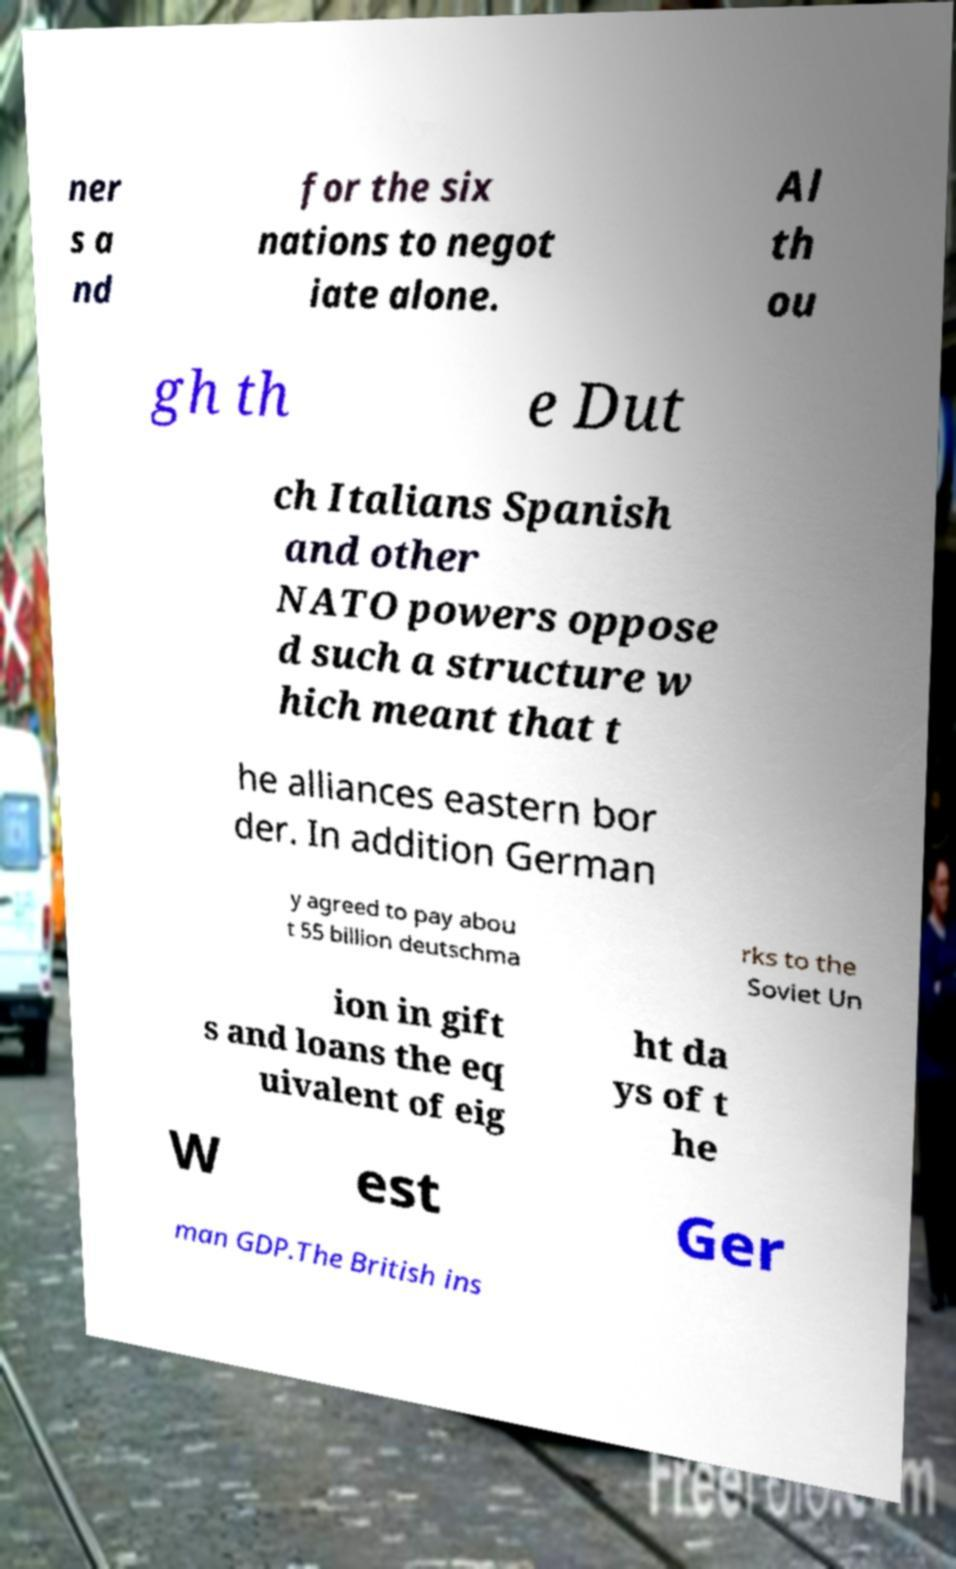For documentation purposes, I need the text within this image transcribed. Could you provide that? ner s a nd for the six nations to negot iate alone. Al th ou gh th e Dut ch Italians Spanish and other NATO powers oppose d such a structure w hich meant that t he alliances eastern bor der. In addition German y agreed to pay abou t 55 billion deutschma rks to the Soviet Un ion in gift s and loans the eq uivalent of eig ht da ys of t he W est Ger man GDP.The British ins 